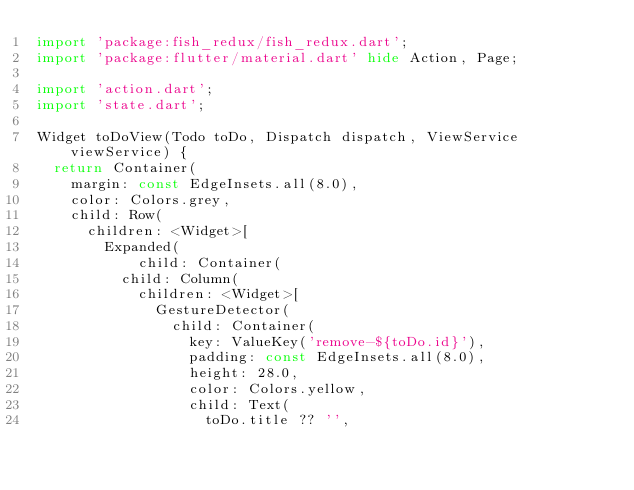Convert code to text. <code><loc_0><loc_0><loc_500><loc_500><_Dart_>import 'package:fish_redux/fish_redux.dart';
import 'package:flutter/material.dart' hide Action, Page;

import 'action.dart';
import 'state.dart';

Widget toDoView(Todo toDo, Dispatch dispatch, ViewService viewService) {
  return Container(
    margin: const EdgeInsets.all(8.0),
    color: Colors.grey,
    child: Row(
      children: <Widget>[
        Expanded(
            child: Container(
          child: Column(
            children: <Widget>[
              GestureDetector(
                child: Container(
                  key: ValueKey('remove-${toDo.id}'),
                  padding: const EdgeInsets.all(8.0),
                  height: 28.0,
                  color: Colors.yellow,
                  child: Text(
                    toDo.title ?? '',</code> 